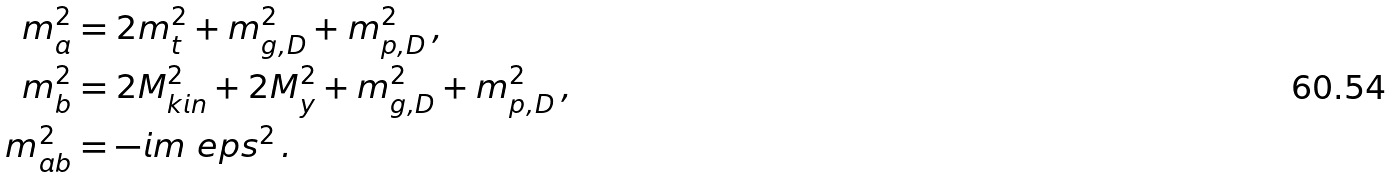Convert formula to latex. <formula><loc_0><loc_0><loc_500><loc_500>m _ { a } ^ { 2 } & = 2 m _ { t } ^ { 2 } + m _ { g , D } ^ { 2 } + m _ { p , D } ^ { 2 } \, , \\ m _ { b } ^ { 2 } & = 2 M _ { k i n } ^ { 2 } + 2 M _ { y } ^ { 2 } + m _ { g , D } ^ { 2 } + m _ { p , D } ^ { 2 } \, , \\ m _ { a b } ^ { 2 } & = - i m _ { \ } e p s ^ { 2 } \, .</formula> 